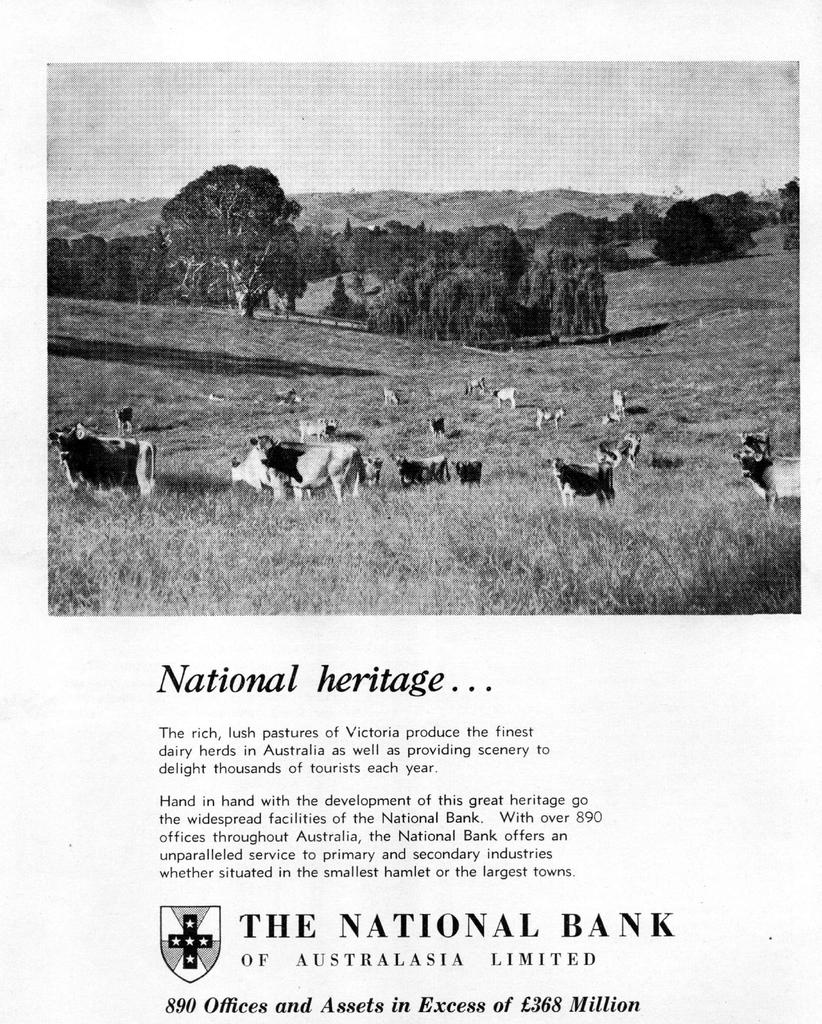What is on the page that is visible in the image? The image contains a page with writing on it. What other subjects can be seen in the image besides the page with writing? There are animals and trees visible in the image. What is the price of the game being played by the donkey in the image? There is no game or donkey present in the image, so it is not possible to determine the price of a game being played by a donkey. 